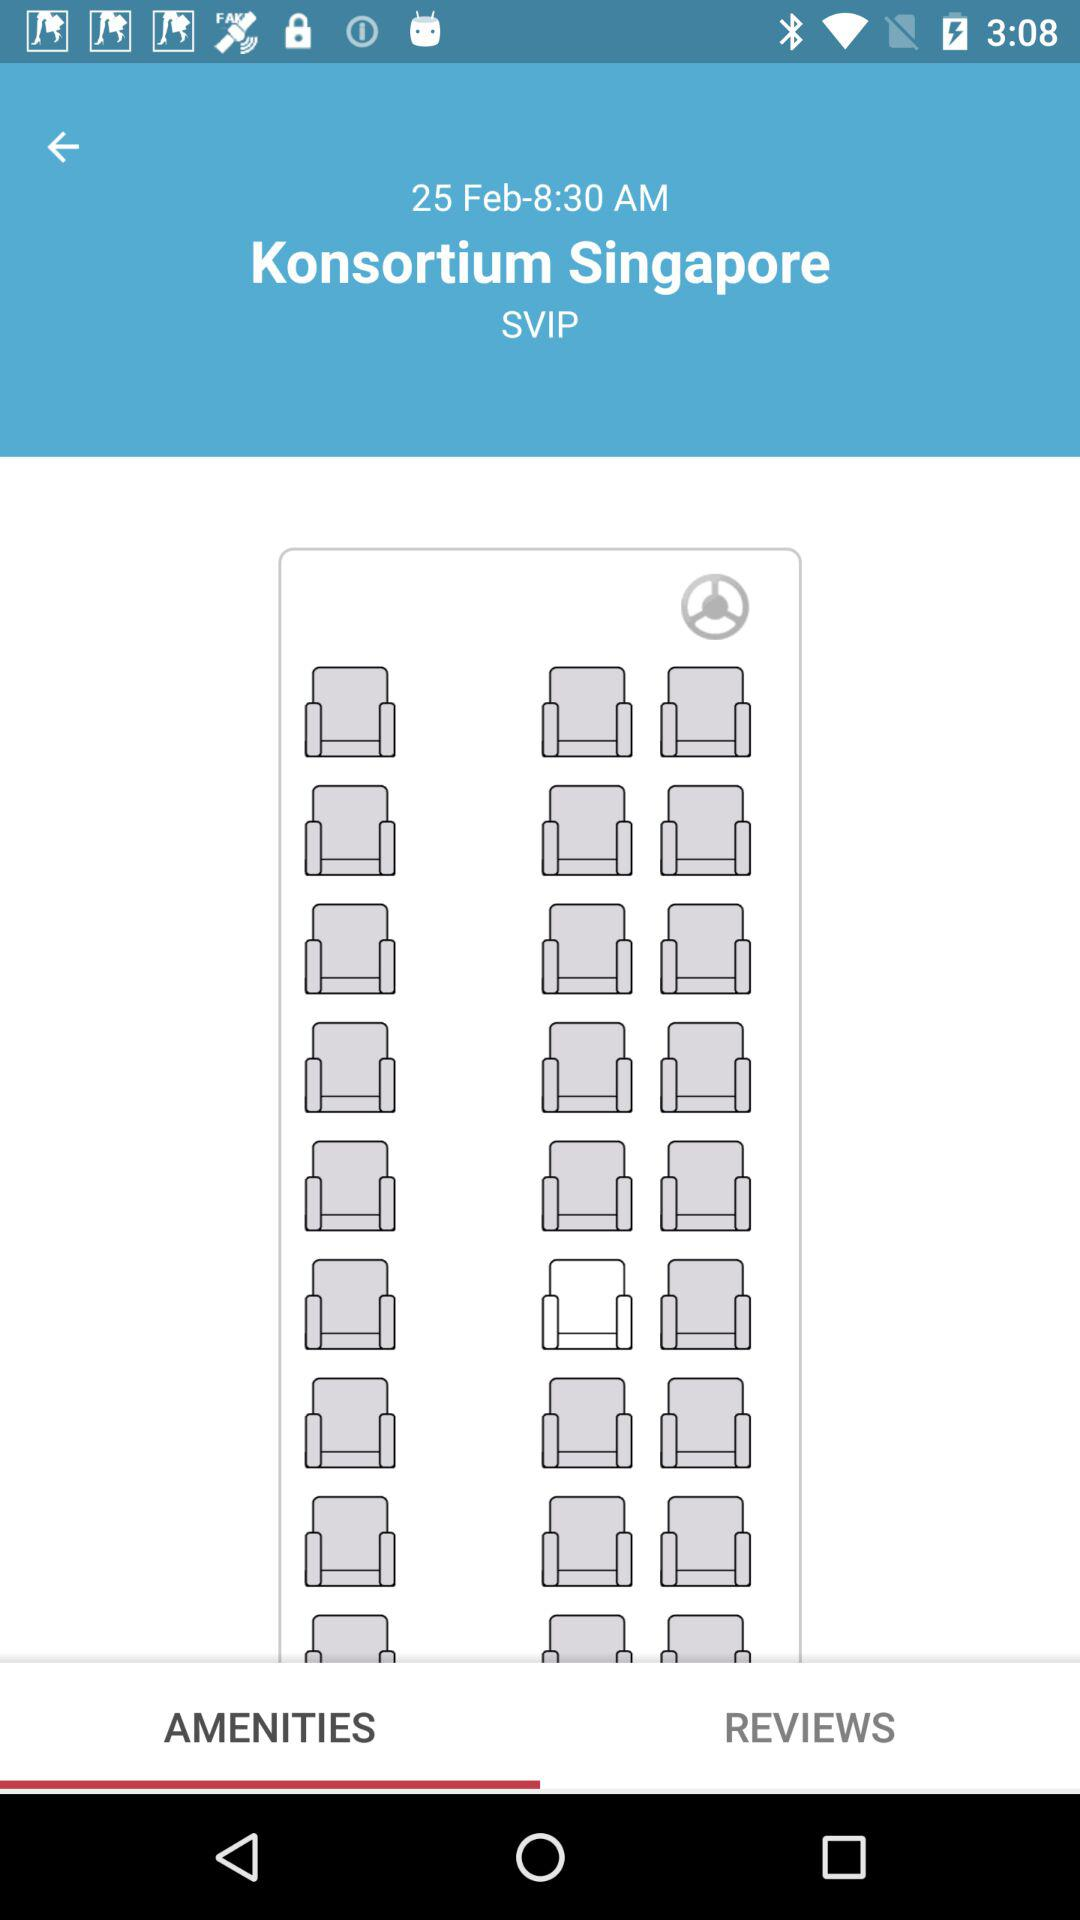What is the date? The date is February 25. 